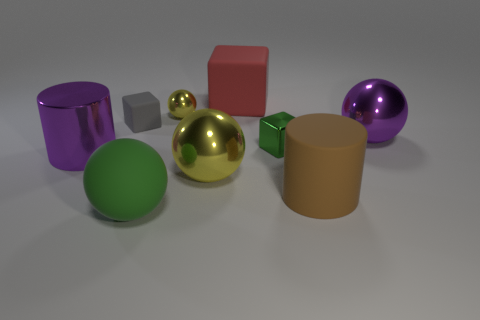Subtract 1 balls. How many balls are left? 3 Add 1 large blocks. How many objects exist? 10 Subtract all cubes. How many objects are left? 6 Subtract 0 gray balls. How many objects are left? 9 Subtract all large cyan matte spheres. Subtract all large purple shiny cylinders. How many objects are left? 8 Add 9 large green things. How many large green things are left? 10 Add 2 big blue shiny cylinders. How many big blue shiny cylinders exist? 2 